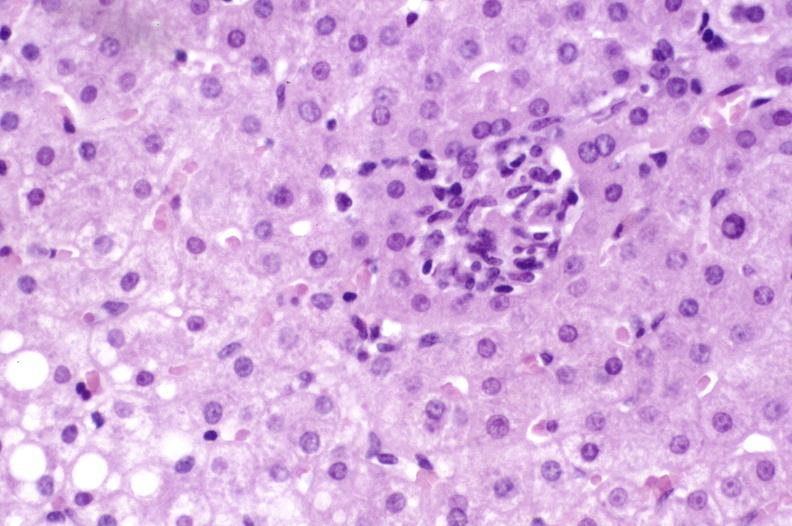s view of head with scalp present?
Answer the question using a single word or phrase. No 